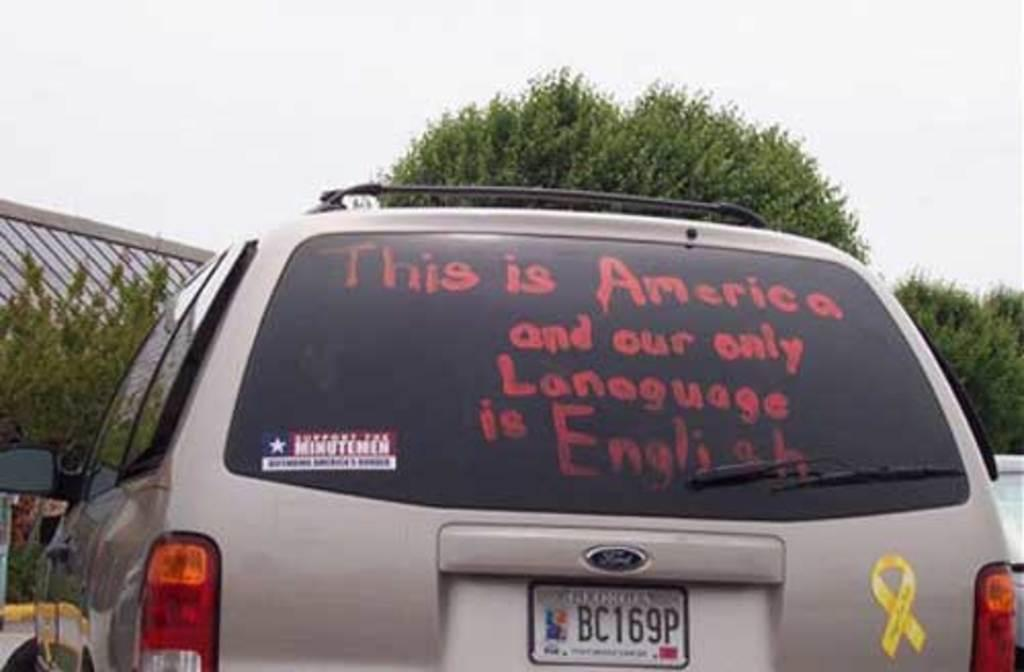<image>
Provide a brief description of the given image. A metallic SUV says, "This is America and our only language is English". 